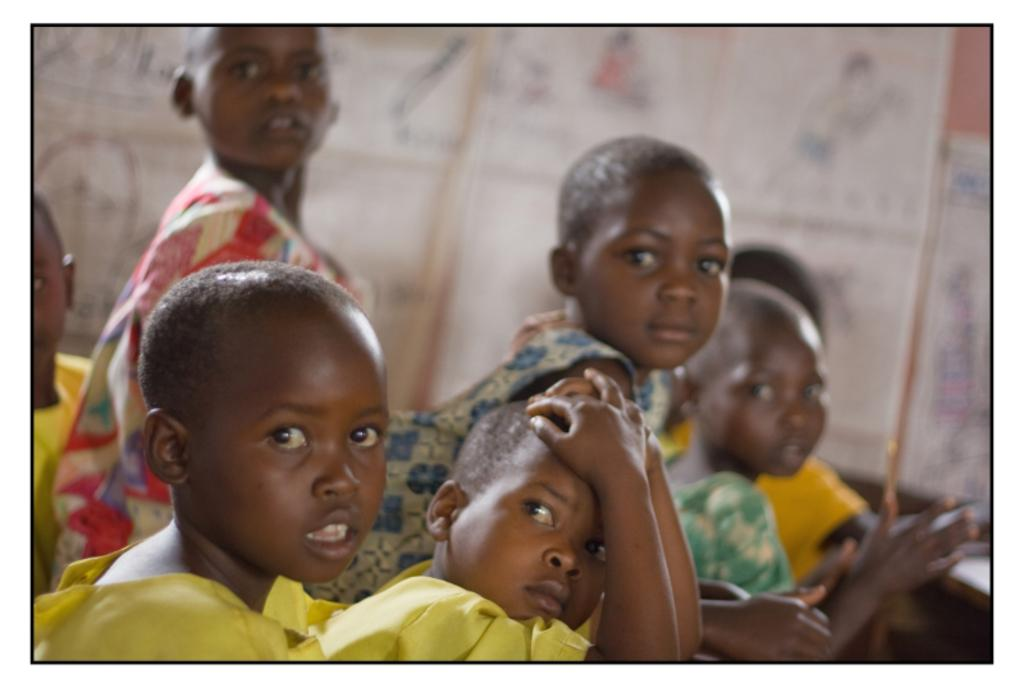What is the main subject of the image? The main subject of the image is a group of people. Can you describe the positions of the people in the image? Some people are sitting, while others are standing. What is the person in front wearing? The person in front is wearing a yellow dress. How would you describe the background of the image? The background of the image is blurred. How many beds can be seen in the image? There are no beds present in the image; it features a group of people with some sitting and others standing. 